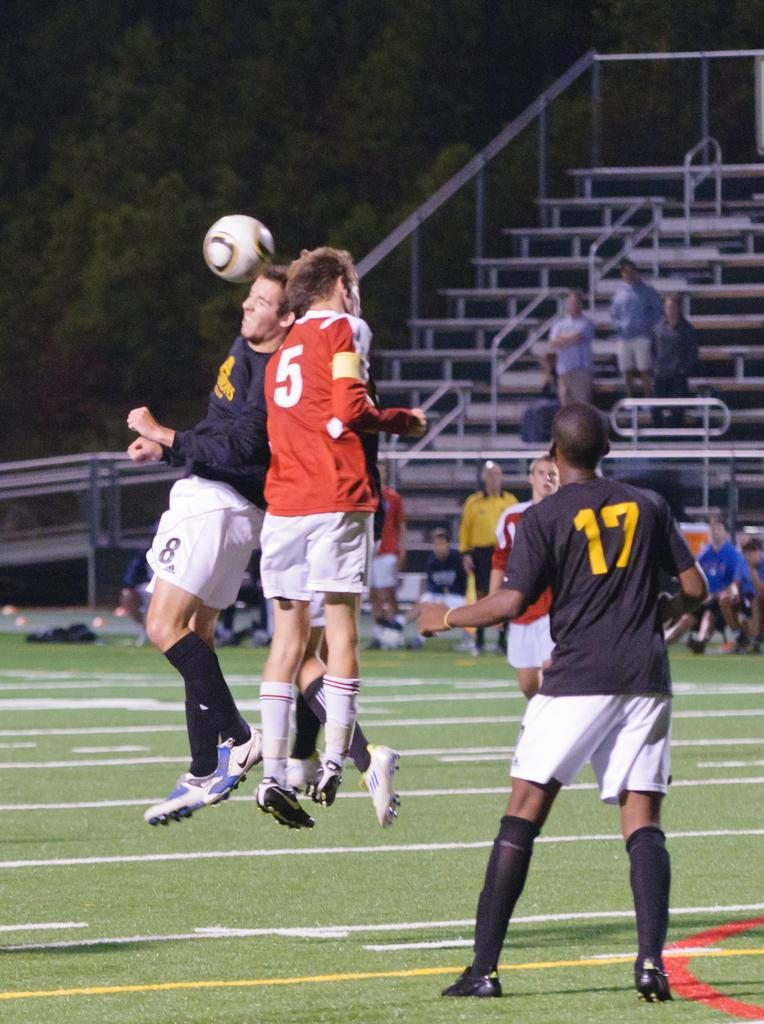<image>
Describe the image concisely. A soccer game where player 8 from the blue team and player 5 from the red team both try to head butt the ball. 